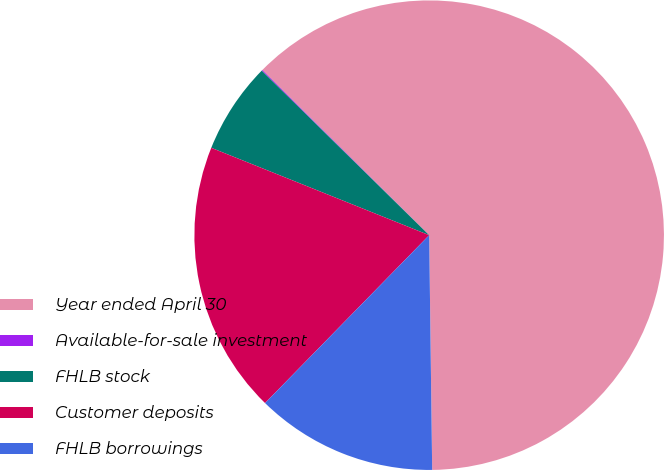Convert chart. <chart><loc_0><loc_0><loc_500><loc_500><pie_chart><fcel>Year ended April 30<fcel>Available-for-sale investment<fcel>FHLB stock<fcel>Customer deposits<fcel>FHLB borrowings<nl><fcel>62.37%<fcel>0.06%<fcel>6.29%<fcel>18.75%<fcel>12.52%<nl></chart> 